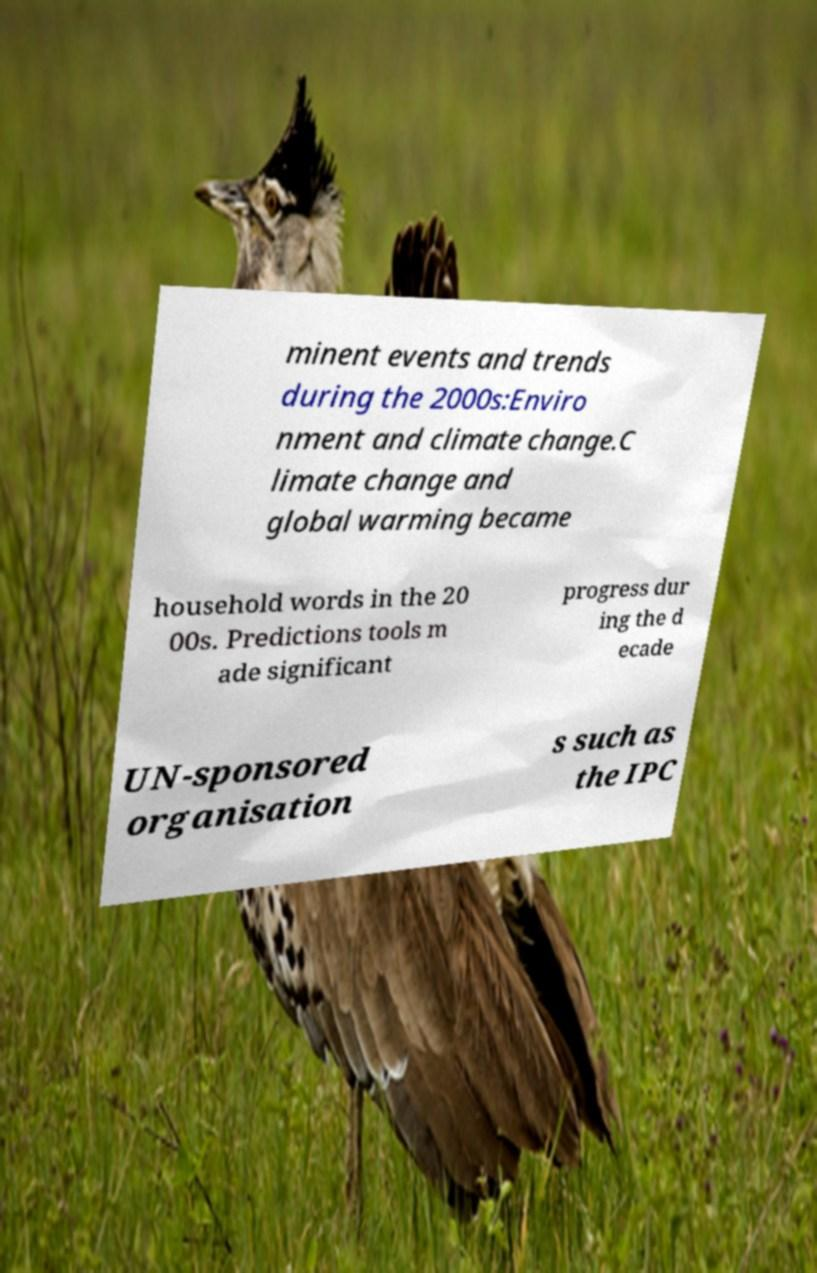Could you extract and type out the text from this image? minent events and trends during the 2000s:Enviro nment and climate change.C limate change and global warming became household words in the 20 00s. Predictions tools m ade significant progress dur ing the d ecade UN-sponsored organisation s such as the IPC 